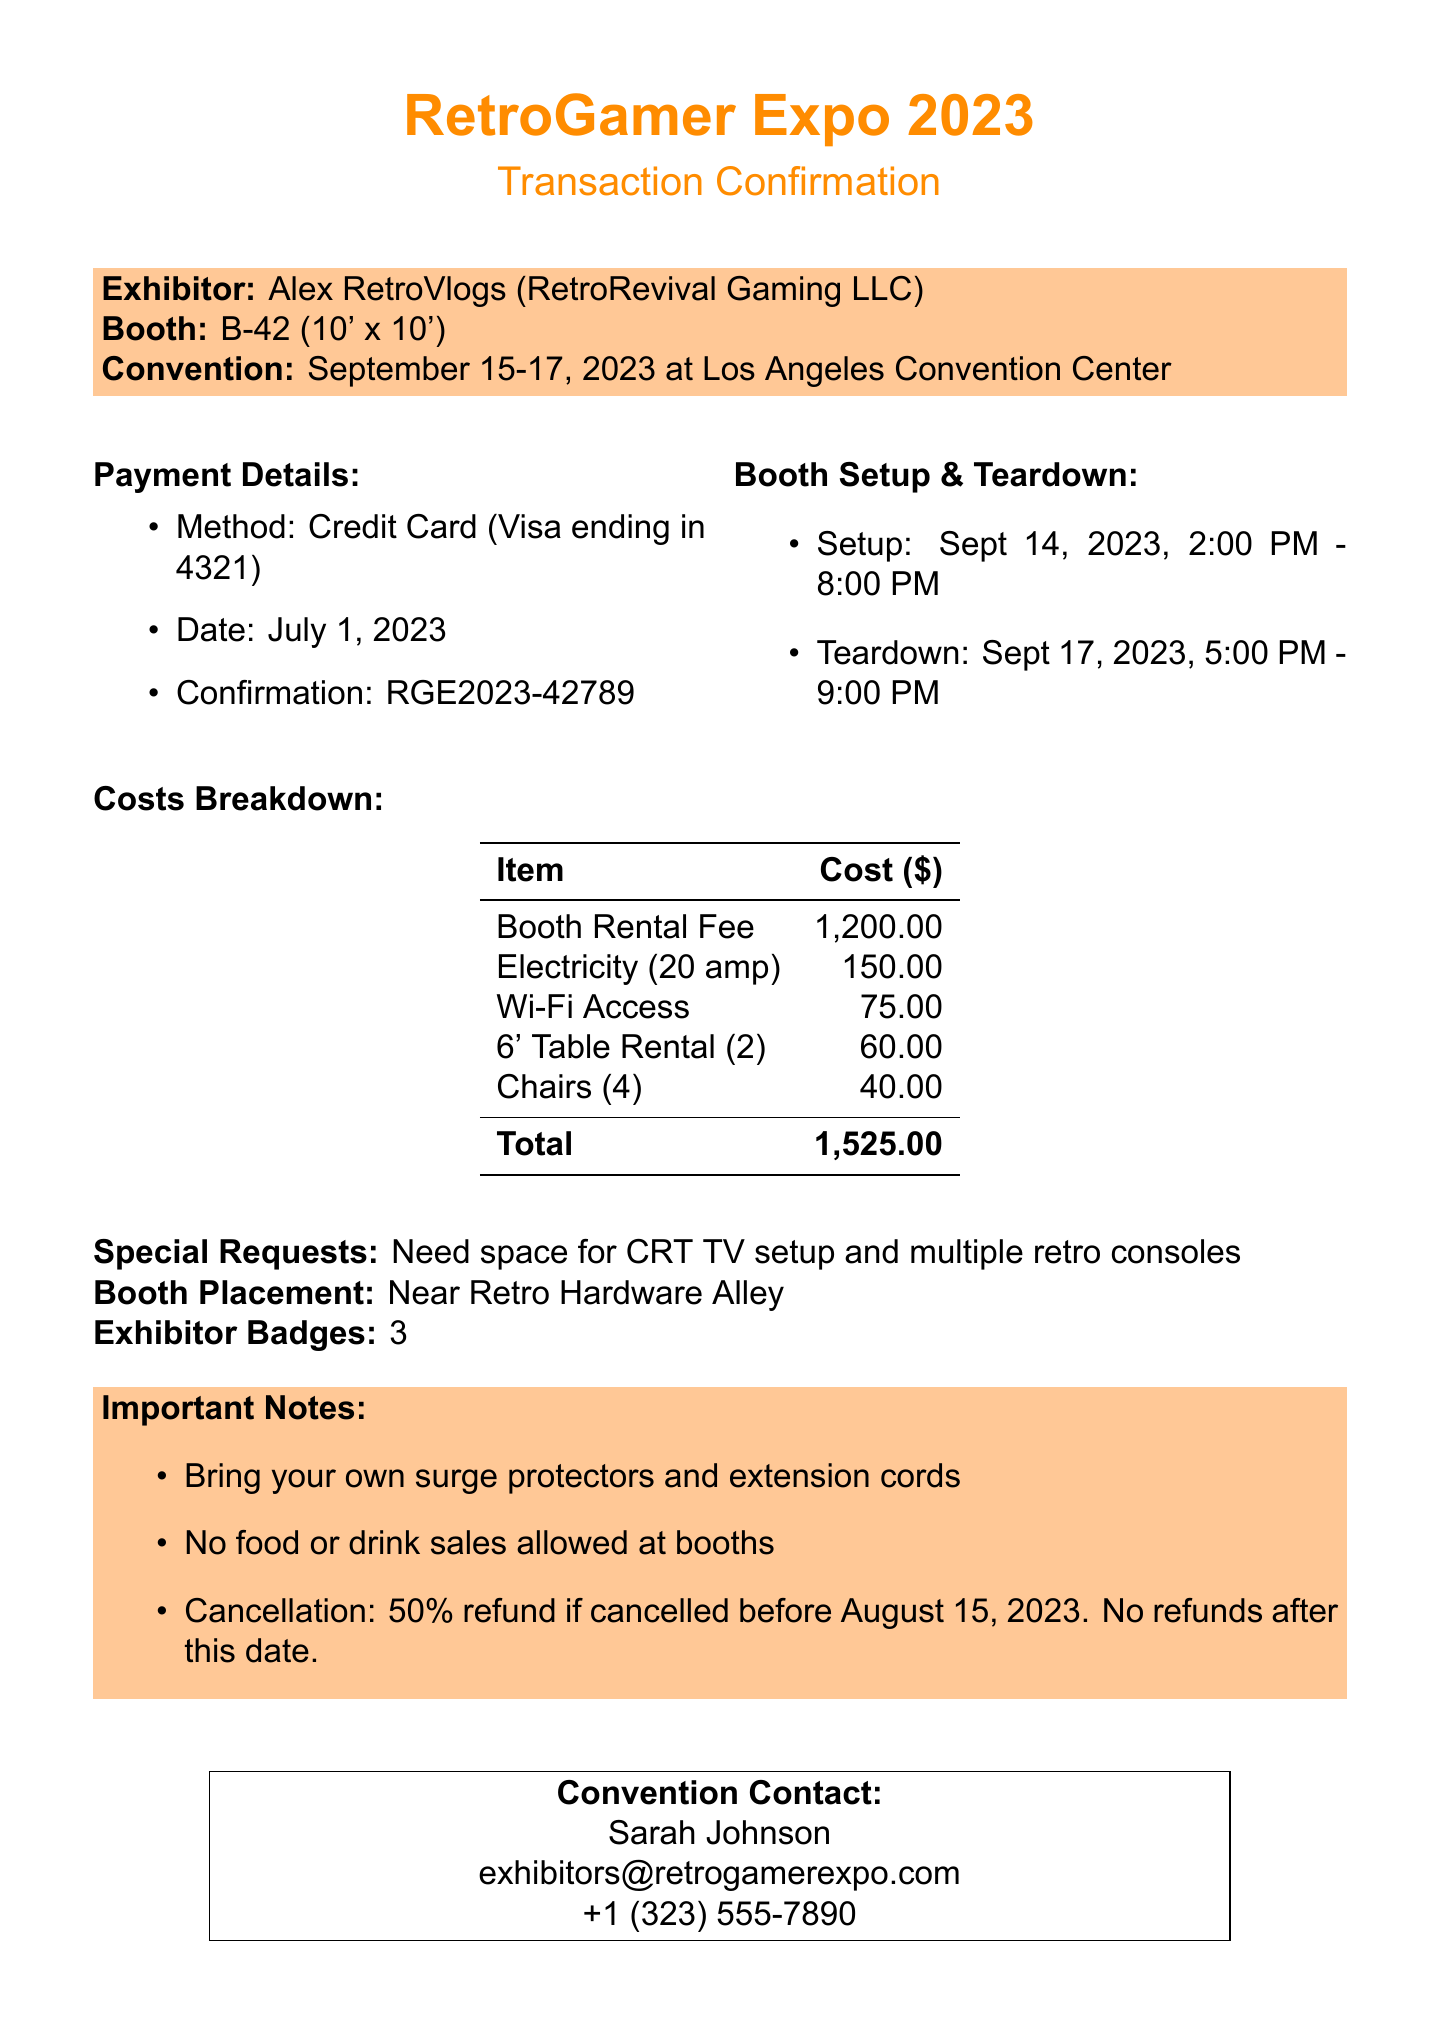what is the name of the convention? The name of the convention is explicitly stated in the document.
Answer: RetroGamer Expo 2023 what is the booth number? The booth number is specified in the document for the exhibitor.
Answer: B-42 how much is the booth rental fee? The booth rental fee is listed in the costs breakdown section of the document.
Answer: 1200.00 when is the setup time scheduled? The setup time is provided in the booth setup & teardown section of the document.
Answer: September 14, 2023, 2:00 PM - 8:00 PM who is the contact person for the convention? The document includes the name of the convention contact person.
Answer: Sarah Johnson what is the total cost of the rental including additional services? The total cost combines the booth rental fee and additional services, which is mentioned towards the end.
Answer: 1525.00 how many exhibitor badges are included? The number of exhibitor badges is explicitly mentioned in the document.
Answer: 3 what is the cancellation policy? The cancellation policy is detailed in the important notes section, specifying conditions for refunds.
Answer: 50% refund if cancelled before August 15, 2023. No refunds after this date what special request has been made? The document notes any special requests made by the exhibitor.
Answer: Need space for CRT TV setup and multiple retro consoles 